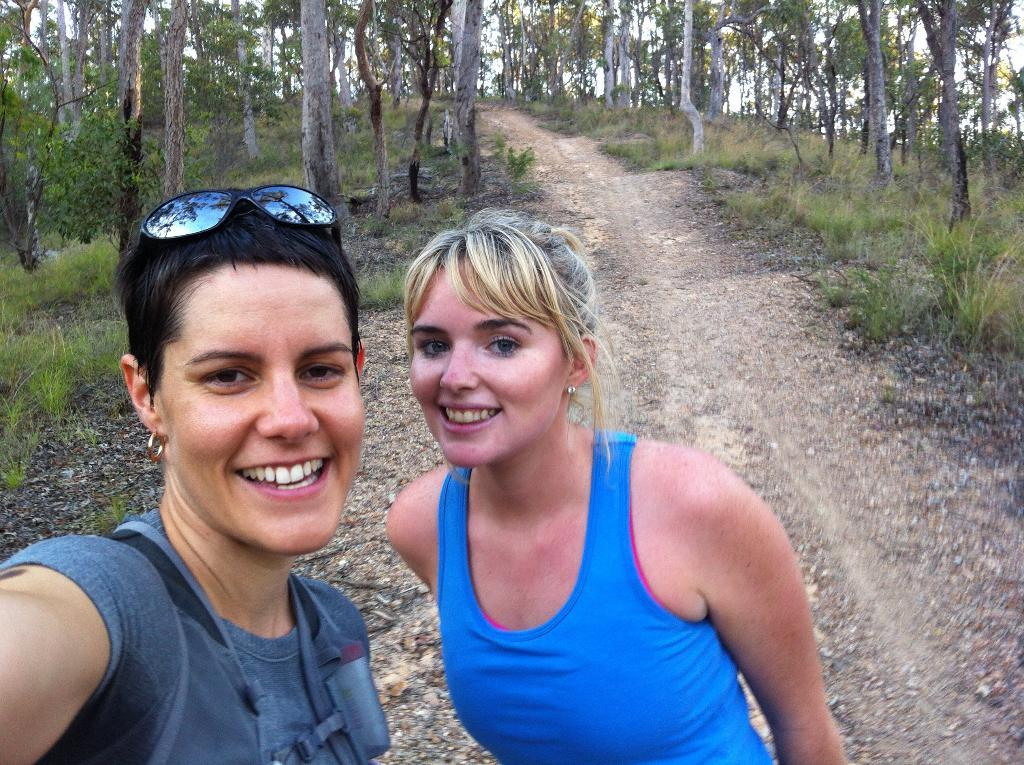How many people are in the image? There are two persons in the image. What is the facial expression of the persons in the image? The persons are smiling. What type of vegetation can be seen in the image? There is grass, plants, and trees in the image. What is visible in the background of the image? The sky is visible in the background of the image. What type of prose can be heard being recited by the persons in the image? There is no indication in the image that the persons are reciting any prose, so it cannot be determined from the picture. Can you describe the color of the rose in the image? There is no rose present in the image. 